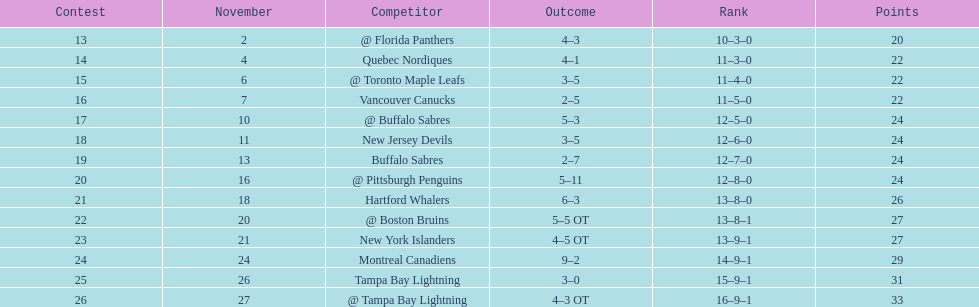What other team had the closest amount of wins? New York Islanders. 